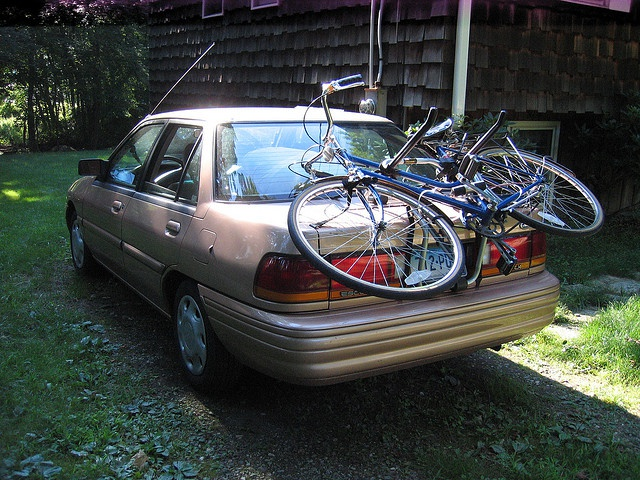Describe the objects in this image and their specific colors. I can see car in black, gray, white, and darkgray tones and bicycle in black, white, gray, and darkgray tones in this image. 